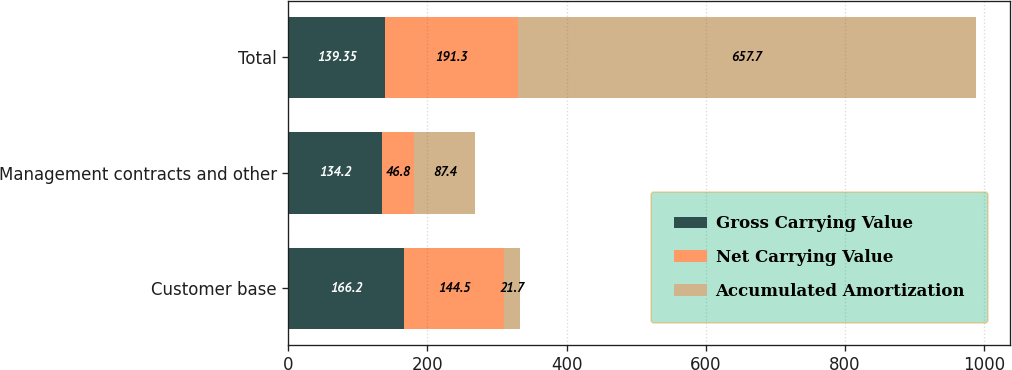<chart> <loc_0><loc_0><loc_500><loc_500><stacked_bar_chart><ecel><fcel>Customer base<fcel>Management contracts and other<fcel>Total<nl><fcel>Gross Carrying Value<fcel>166.2<fcel>134.2<fcel>139.35<nl><fcel>Net Carrying Value<fcel>144.5<fcel>46.8<fcel>191.3<nl><fcel>Accumulated Amortization<fcel>21.7<fcel>87.4<fcel>657.7<nl></chart> 